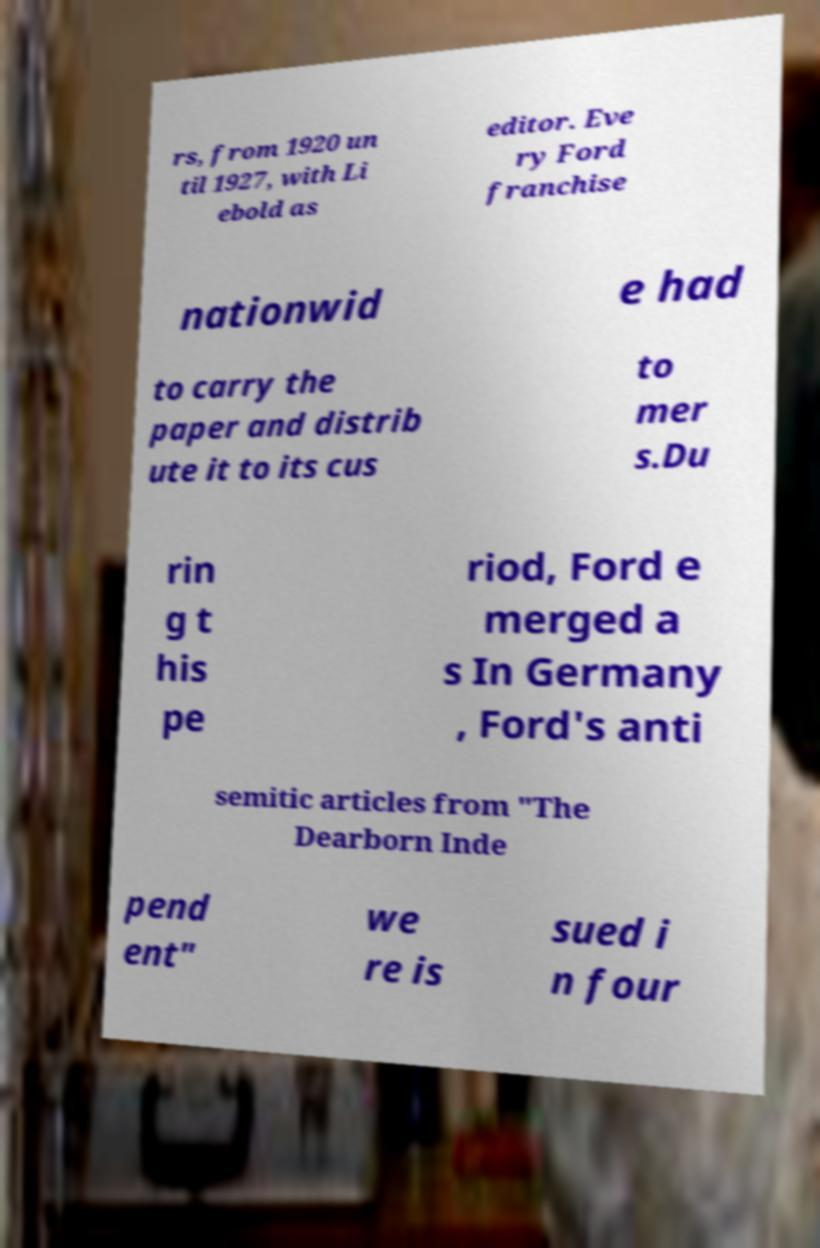Please read and relay the text visible in this image. What does it say? rs, from 1920 un til 1927, with Li ebold as editor. Eve ry Ford franchise nationwid e had to carry the paper and distrib ute it to its cus to mer s.Du rin g t his pe riod, Ford e merged a s In Germany , Ford's anti semitic articles from "The Dearborn Inde pend ent" we re is sued i n four 